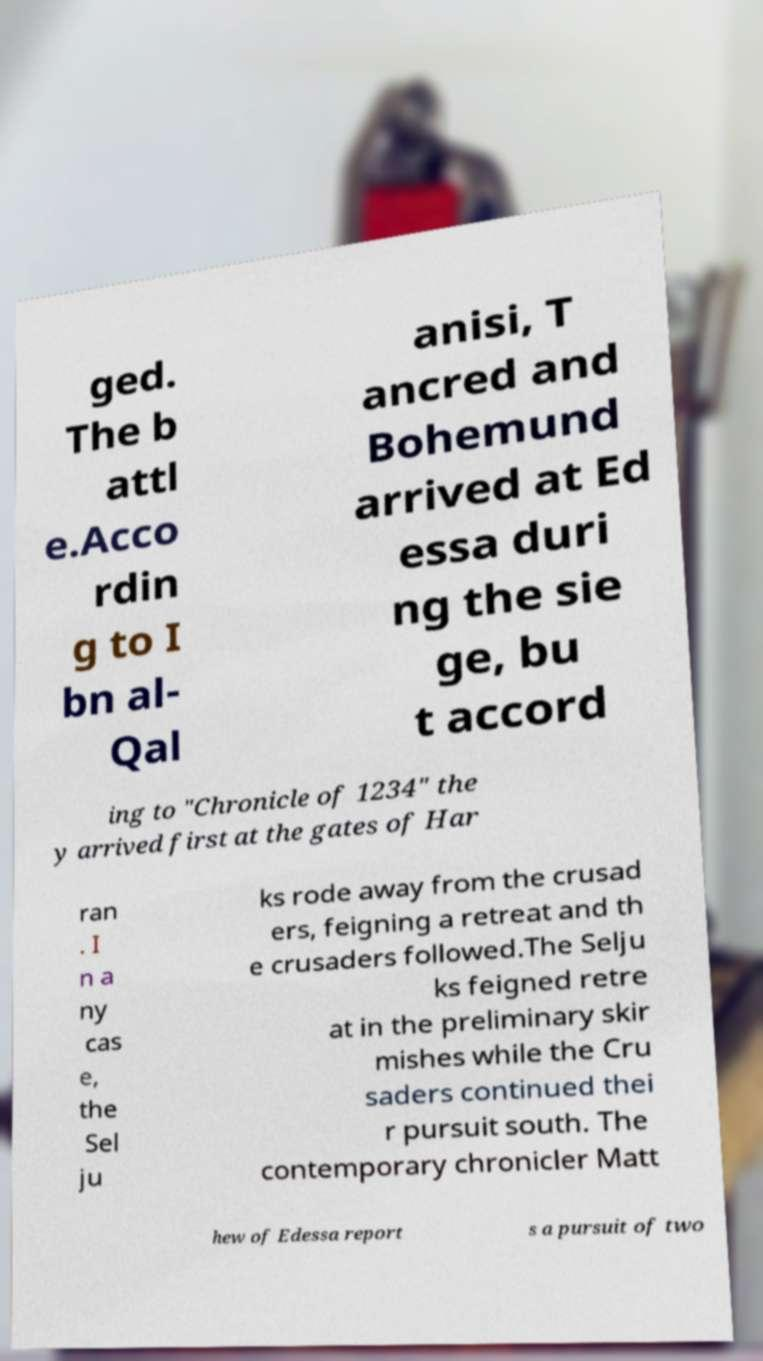Could you assist in decoding the text presented in this image and type it out clearly? ged. The b attl e.Acco rdin g to I bn al- Qal anisi, T ancred and Bohemund arrived at Ed essa duri ng the sie ge, bu t accord ing to "Chronicle of 1234" the y arrived first at the gates of Har ran . I n a ny cas e, the Sel ju ks rode away from the crusad ers, feigning a retreat and th e crusaders followed.The Selju ks feigned retre at in the preliminary skir mishes while the Cru saders continued thei r pursuit south. The contemporary chronicler Matt hew of Edessa report s a pursuit of two 